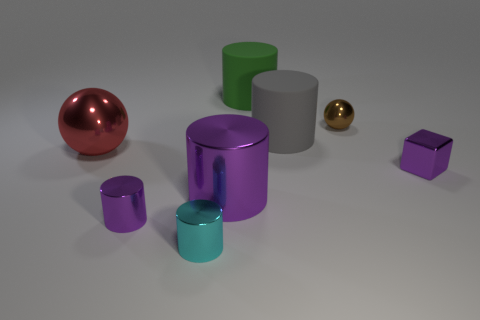There is a big rubber thing that is to the right of the green thing; does it have the same shape as the large metal thing that is in front of the red ball?
Keep it short and to the point. Yes. Are there any green cylinders of the same size as the brown object?
Offer a very short reply. No. Are there the same number of large rubber cylinders in front of the big red metal thing and matte things that are behind the gray thing?
Offer a very short reply. No. Is the big cylinder in front of the small block made of the same material as the small purple thing to the right of the green object?
Your answer should be very brief. Yes. What is the small purple cylinder made of?
Your response must be concise. Metal. What number of other things are the same color as the big shiny cylinder?
Make the answer very short. 2. Does the small metallic cube have the same color as the tiny shiny ball?
Keep it short and to the point. No. What number of small cyan metal cylinders are there?
Offer a very short reply. 1. What material is the small purple thing left of the purple thing right of the tiny brown thing?
Keep it short and to the point. Metal. There is a purple object that is the same size as the gray matte thing; what material is it?
Keep it short and to the point. Metal. 